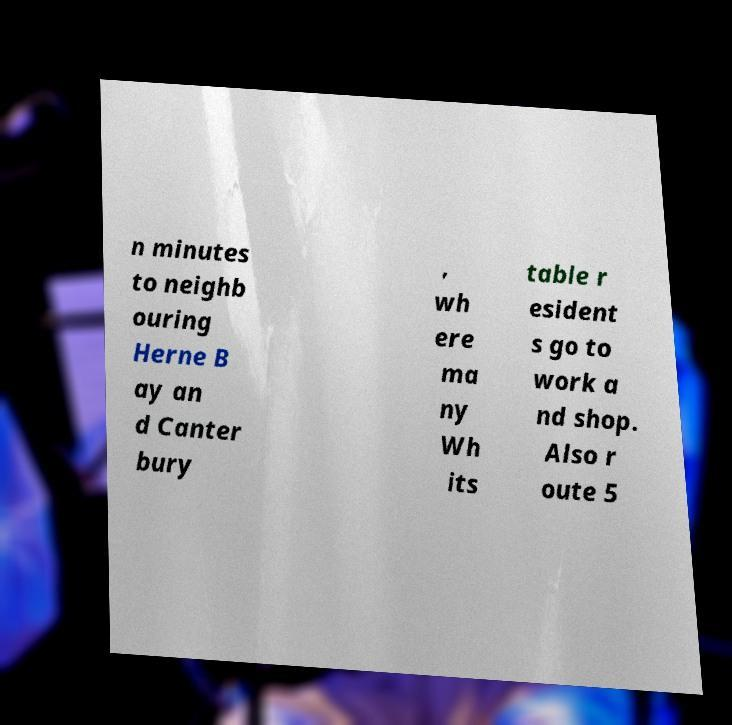Please identify and transcribe the text found in this image. n minutes to neighb ouring Herne B ay an d Canter bury , wh ere ma ny Wh its table r esident s go to work a nd shop. Also r oute 5 